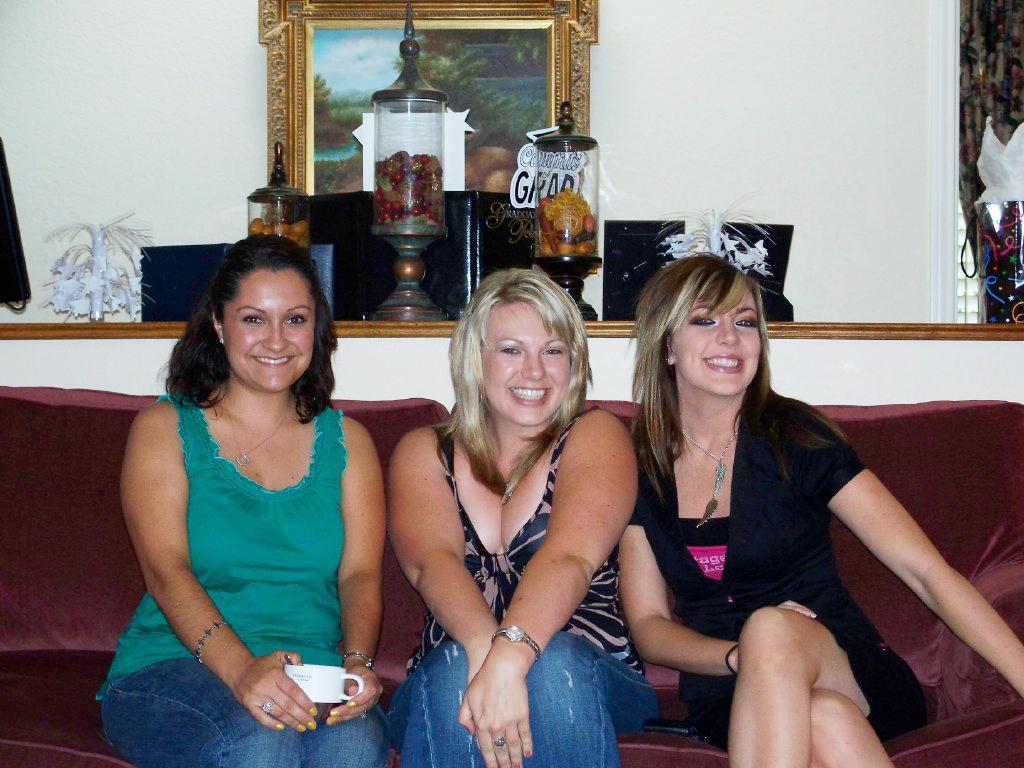Can you describe this image briefly? In the image we can see three women sitting on the sofa, they are wearing clothes, neck chain and two of them are wearing a wristwatch. This is a finger ring, bracelet, teacup, frame, wall, decoration and food items in the container. These three women are smiling. 